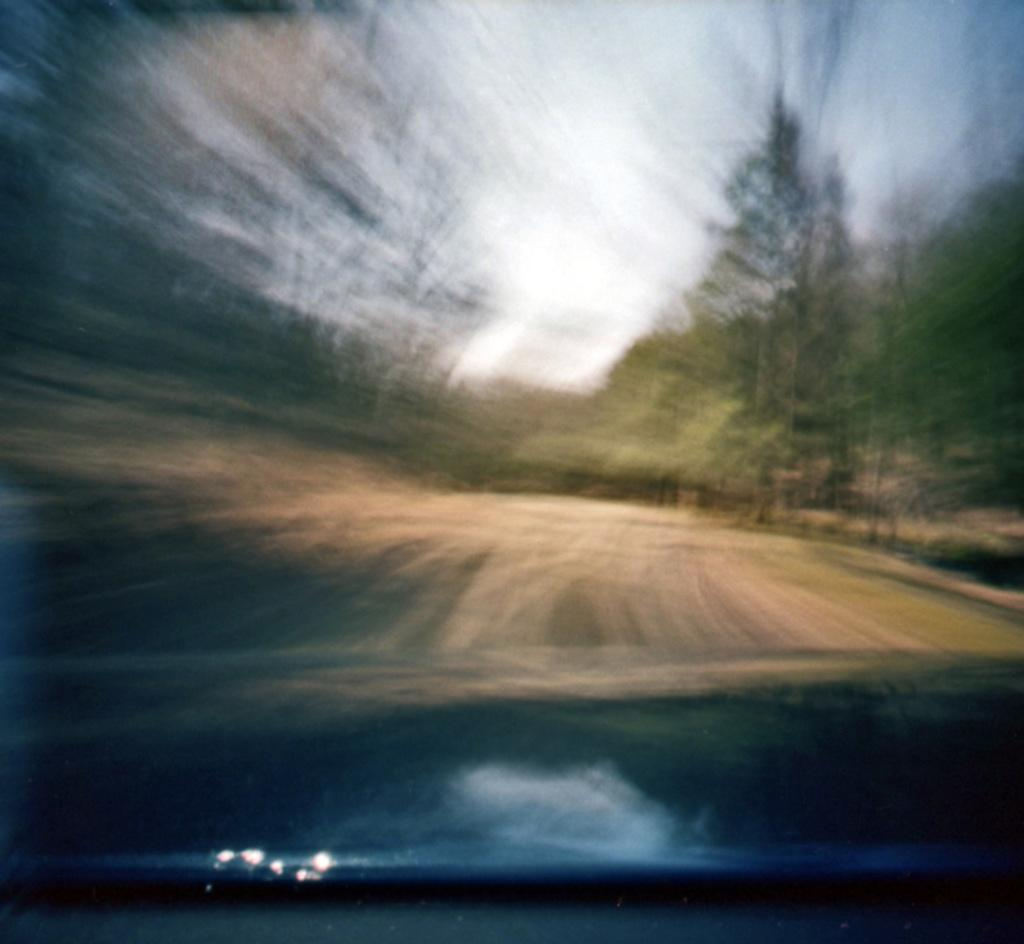What is the primary viewpoint of the image? The image is viewed through the windshield of a car. What part of the car can be seen in the image? The car bonnet is visible in the image. What is the main feature of the landscape in the image? The road is visible in the image. What type of natural elements are present in the image? Trees are present in the image. What is visible above the landscape in the image? The sky is visible in the image. What type of thrill can be experienced by the son in the image? There is no son present in the image, and therefore no such experience can be observed. What type of development can be seen in the image? The image does not show any development or construction; it primarily features a road, trees, and the sky. 